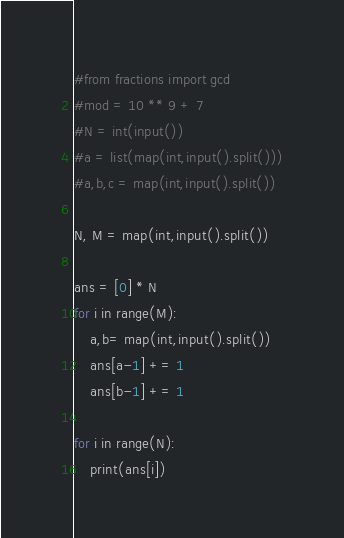<code> <loc_0><loc_0><loc_500><loc_500><_Python_>#from fractions import gcd
#mod = 10 ** 9 + 7
#N = int(input())
#a = list(map(int,input().split()))
#a,b,c = map(int,input().split())

N, M = map(int,input().split())

ans = [0] * N
for i in range(M):
    a,b= map(int,input().split())
    ans[a-1] += 1
    ans[b-1] += 1

for i in range(N):
    print(ans[i])
</code> 